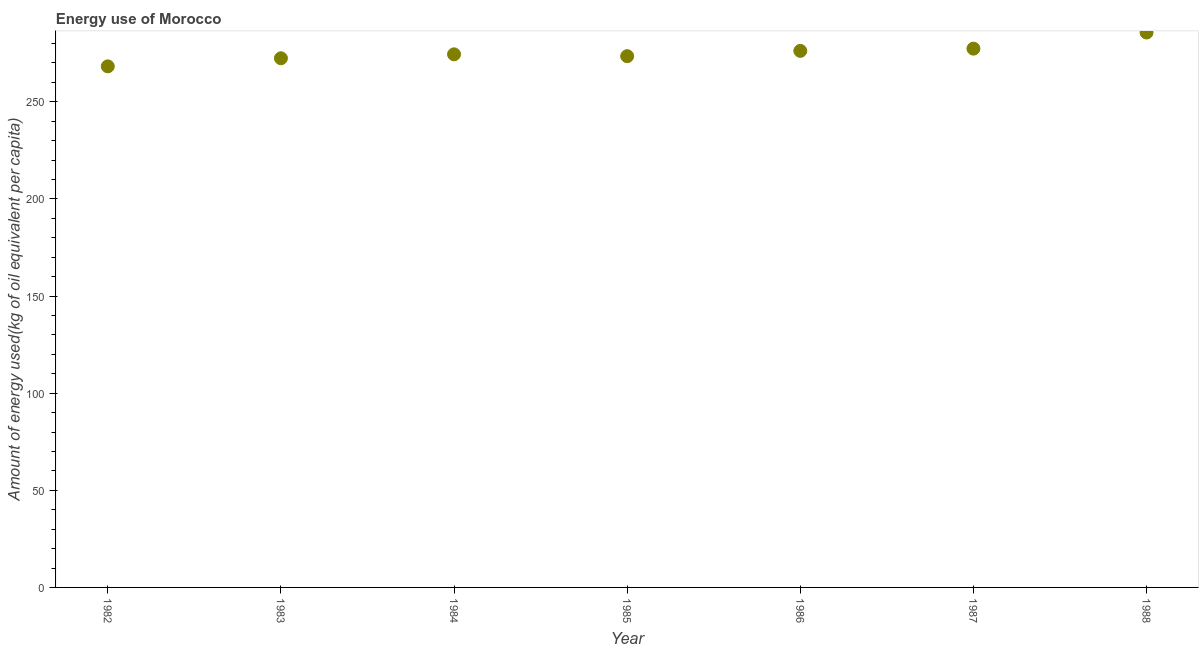What is the amount of energy used in 1985?
Ensure brevity in your answer.  273.5. Across all years, what is the maximum amount of energy used?
Your response must be concise. 285.68. Across all years, what is the minimum amount of energy used?
Keep it short and to the point. 268.26. What is the sum of the amount of energy used?
Provide a short and direct response. 1927.93. What is the difference between the amount of energy used in 1983 and 1984?
Offer a very short reply. -2.03. What is the average amount of energy used per year?
Provide a succinct answer. 275.42. What is the median amount of energy used?
Offer a very short reply. 274.45. What is the ratio of the amount of energy used in 1982 to that in 1984?
Provide a short and direct response. 0.98. Is the amount of energy used in 1982 less than that in 1987?
Provide a short and direct response. Yes. What is the difference between the highest and the second highest amount of energy used?
Provide a succinct answer. 8.3. Is the sum of the amount of energy used in 1983 and 1987 greater than the maximum amount of energy used across all years?
Provide a short and direct response. Yes. What is the difference between the highest and the lowest amount of energy used?
Ensure brevity in your answer.  17.43. Does the amount of energy used monotonically increase over the years?
Offer a very short reply. No. How many years are there in the graph?
Your response must be concise. 7. What is the difference between two consecutive major ticks on the Y-axis?
Your answer should be compact. 50. Are the values on the major ticks of Y-axis written in scientific E-notation?
Ensure brevity in your answer.  No. Does the graph contain any zero values?
Your answer should be very brief. No. What is the title of the graph?
Provide a short and direct response. Energy use of Morocco. What is the label or title of the Y-axis?
Provide a succinct answer. Amount of energy used(kg of oil equivalent per capita). What is the Amount of energy used(kg of oil equivalent per capita) in 1982?
Make the answer very short. 268.26. What is the Amount of energy used(kg of oil equivalent per capita) in 1983?
Give a very brief answer. 272.42. What is the Amount of energy used(kg of oil equivalent per capita) in 1984?
Provide a short and direct response. 274.45. What is the Amount of energy used(kg of oil equivalent per capita) in 1985?
Offer a terse response. 273.5. What is the Amount of energy used(kg of oil equivalent per capita) in 1986?
Your answer should be very brief. 276.23. What is the Amount of energy used(kg of oil equivalent per capita) in 1987?
Your answer should be very brief. 277.38. What is the Amount of energy used(kg of oil equivalent per capita) in 1988?
Make the answer very short. 285.68. What is the difference between the Amount of energy used(kg of oil equivalent per capita) in 1982 and 1983?
Your answer should be very brief. -4.16. What is the difference between the Amount of energy used(kg of oil equivalent per capita) in 1982 and 1984?
Offer a very short reply. -6.2. What is the difference between the Amount of energy used(kg of oil equivalent per capita) in 1982 and 1985?
Make the answer very short. -5.25. What is the difference between the Amount of energy used(kg of oil equivalent per capita) in 1982 and 1986?
Your answer should be compact. -7.97. What is the difference between the Amount of energy used(kg of oil equivalent per capita) in 1982 and 1987?
Give a very brief answer. -9.13. What is the difference between the Amount of energy used(kg of oil equivalent per capita) in 1982 and 1988?
Your answer should be compact. -17.43. What is the difference between the Amount of energy used(kg of oil equivalent per capita) in 1983 and 1984?
Offer a very short reply. -2.03. What is the difference between the Amount of energy used(kg of oil equivalent per capita) in 1983 and 1985?
Keep it short and to the point. -1.08. What is the difference between the Amount of energy used(kg of oil equivalent per capita) in 1983 and 1986?
Make the answer very short. -3.81. What is the difference between the Amount of energy used(kg of oil equivalent per capita) in 1983 and 1987?
Provide a succinct answer. -4.96. What is the difference between the Amount of energy used(kg of oil equivalent per capita) in 1983 and 1988?
Ensure brevity in your answer.  -13.26. What is the difference between the Amount of energy used(kg of oil equivalent per capita) in 1984 and 1985?
Your answer should be compact. 0.95. What is the difference between the Amount of energy used(kg of oil equivalent per capita) in 1984 and 1986?
Your answer should be compact. -1.78. What is the difference between the Amount of energy used(kg of oil equivalent per capita) in 1984 and 1987?
Your answer should be compact. -2.93. What is the difference between the Amount of energy used(kg of oil equivalent per capita) in 1984 and 1988?
Offer a very short reply. -11.23. What is the difference between the Amount of energy used(kg of oil equivalent per capita) in 1985 and 1986?
Your response must be concise. -2.73. What is the difference between the Amount of energy used(kg of oil equivalent per capita) in 1985 and 1987?
Give a very brief answer. -3.88. What is the difference between the Amount of energy used(kg of oil equivalent per capita) in 1985 and 1988?
Your answer should be very brief. -12.18. What is the difference between the Amount of energy used(kg of oil equivalent per capita) in 1986 and 1987?
Provide a short and direct response. -1.15. What is the difference between the Amount of energy used(kg of oil equivalent per capita) in 1986 and 1988?
Offer a terse response. -9.45. What is the difference between the Amount of energy used(kg of oil equivalent per capita) in 1987 and 1988?
Provide a short and direct response. -8.3. What is the ratio of the Amount of energy used(kg of oil equivalent per capita) in 1982 to that in 1983?
Provide a short and direct response. 0.98. What is the ratio of the Amount of energy used(kg of oil equivalent per capita) in 1982 to that in 1984?
Offer a terse response. 0.98. What is the ratio of the Amount of energy used(kg of oil equivalent per capita) in 1982 to that in 1988?
Provide a succinct answer. 0.94. What is the ratio of the Amount of energy used(kg of oil equivalent per capita) in 1983 to that in 1985?
Keep it short and to the point. 1. What is the ratio of the Amount of energy used(kg of oil equivalent per capita) in 1983 to that in 1986?
Keep it short and to the point. 0.99. What is the ratio of the Amount of energy used(kg of oil equivalent per capita) in 1983 to that in 1988?
Make the answer very short. 0.95. What is the ratio of the Amount of energy used(kg of oil equivalent per capita) in 1984 to that in 1986?
Offer a very short reply. 0.99. What is the ratio of the Amount of energy used(kg of oil equivalent per capita) in 1984 to that in 1987?
Your answer should be compact. 0.99. What is the ratio of the Amount of energy used(kg of oil equivalent per capita) in 1986 to that in 1987?
Make the answer very short. 1. What is the ratio of the Amount of energy used(kg of oil equivalent per capita) in 1987 to that in 1988?
Offer a terse response. 0.97. 